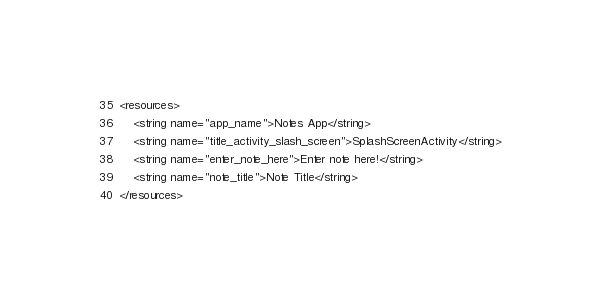<code> <loc_0><loc_0><loc_500><loc_500><_XML_><resources>
    <string name="app_name">Notes App</string>
    <string name="title_activity_slash_screen">SplashScreenActivity</string>
    <string name="enter_note_here">Enter note here!</string>
    <string name="note_title">Note Title</string>
</resources></code> 